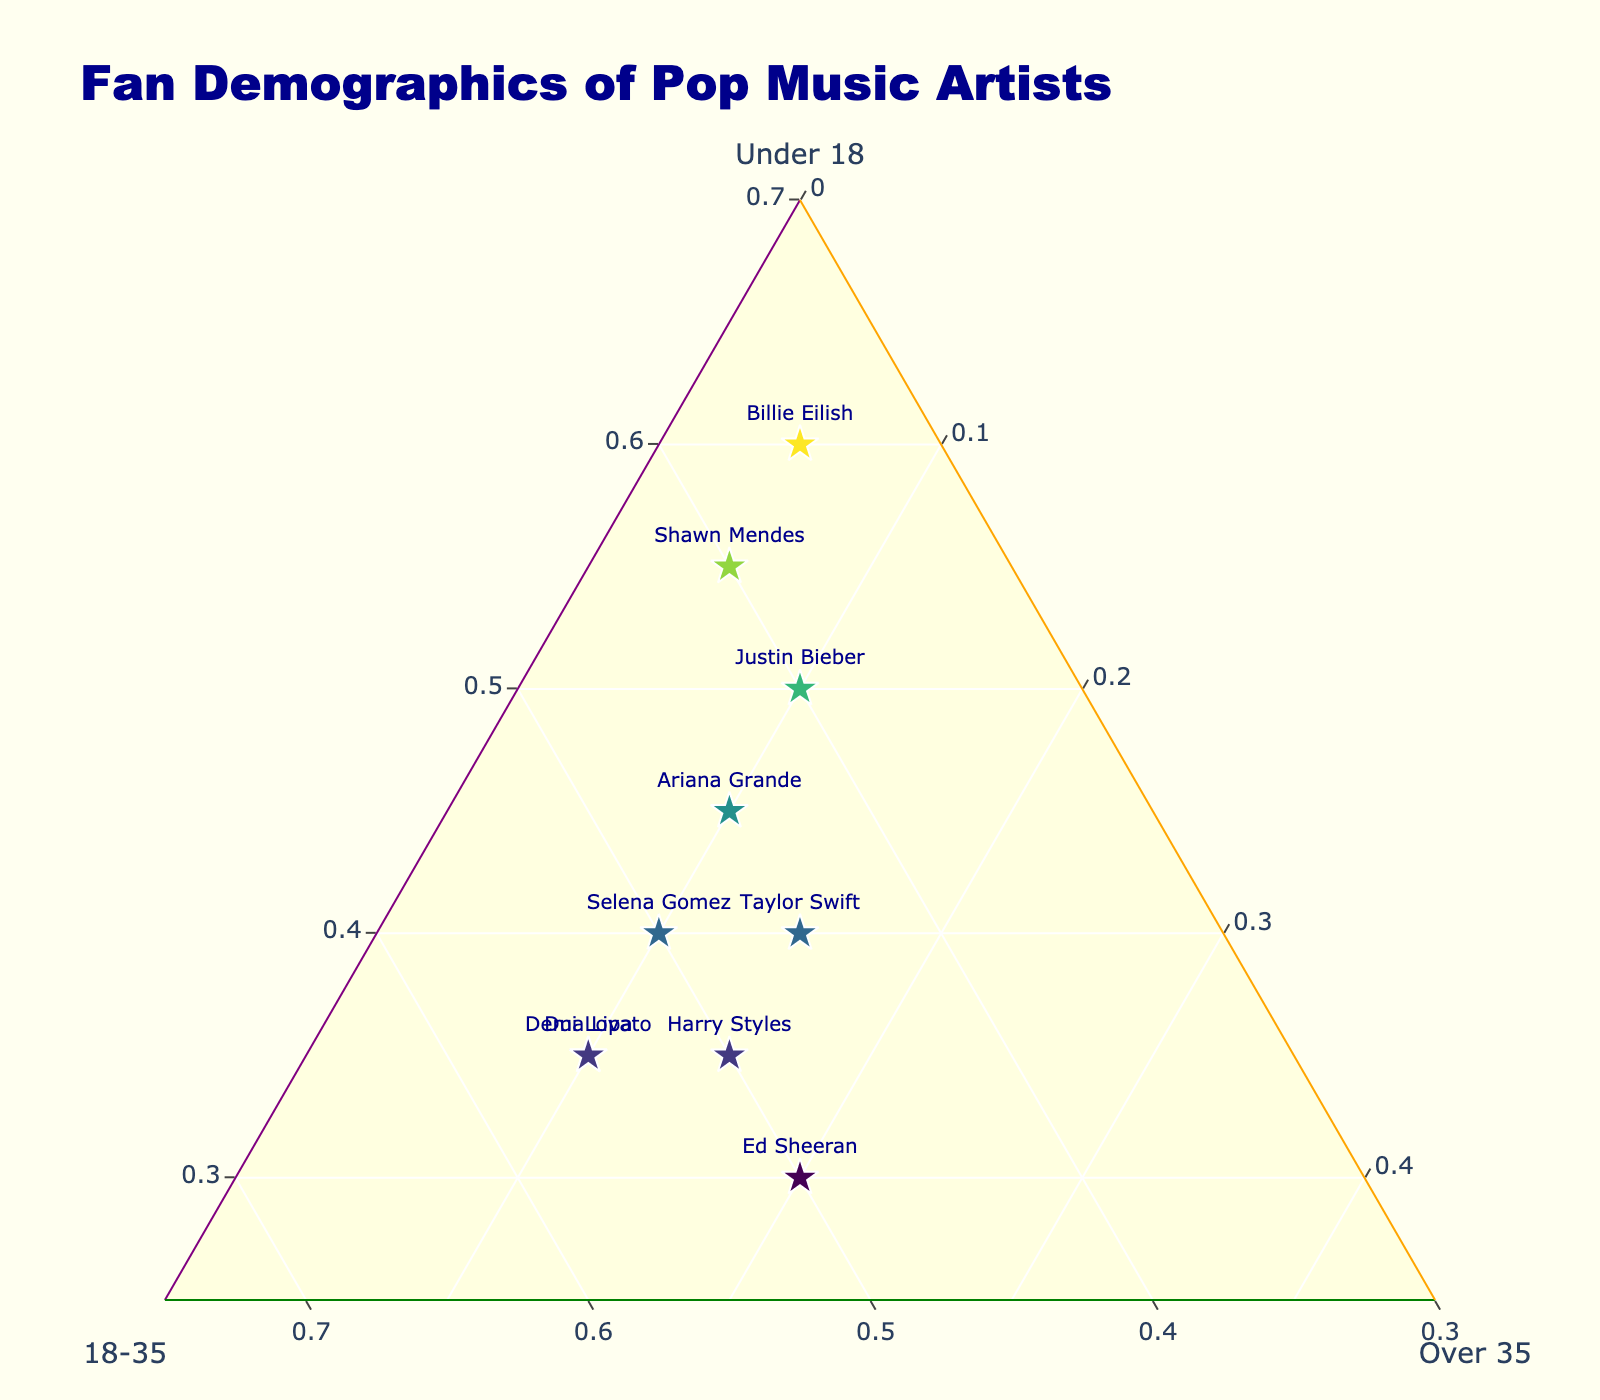What is the title of the plot? The title is usually placed at the top of the plot and describes what the plot is about.
Answer: "Fan Demographics of Pop Music Artists" How many artists have a higher percentage of fans under 18 than fans 18-35? Compare the values in the "Under 18" column to the "18-35" column for each artist and count the number of artists where the value in the "Under 18" column is greater.
Answer: 3 artists (Justin Bieber, Billie Eilish, Shawn Mendes) Which artist has the highest percentage of fans over 35? Identify the data point with the highest value in the 'Over 35' axis.
Answer: Ed Sheeran What is the color of the marker for Billie Eilish? The color of the markers is determined by the percentage of fans under 18, and Billie Eilish has the highest percentage of fans under 18.
Answer: Darker green (upper end of the Viridis colors) How many artists have equal percentages of fans in the 18-35 age group? Count the artists where the value in the '18-35' column is the same.
Answer: 2 artists (Taylor Swift, Ariana Grande) What is the average percentage of fans over 35 for all artists? Sum the percentages in the 'Over 35' column and divide by the number of artists. (15 + 10 + 10 + 20 + 5 + 5 + 10 + 15 + 10 + 10) / 10 = 11
Answer: 11% Who has a larger percentage of fans under 18, Taylor Swift or Harry Styles? Compare the 'Under 18' values for Taylor Swift and Harry Styles.
Answer: Taylor Swift (40%) Between Dua Lipa and Demi Lovato, who has a greater percentage of fans in the 18-35 age group? Compare the '18-35' values for Dua Lipa and Demi Lovato.
Answer: Both have the same (55%) Which artist is closest to having an equal distribution of fans across all three age groups? Calculate the difference between the percentages for each age group for every artist. The artist with the smallest differences has the most equal distribution.
Answer: Ed Sheeran (30%, 50%, 20%) 